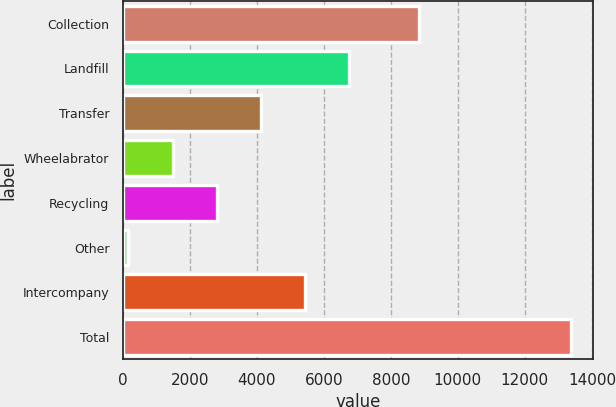<chart> <loc_0><loc_0><loc_500><loc_500><bar_chart><fcel>Collection<fcel>Landfill<fcel>Transfer<fcel>Wheelabrator<fcel>Recycling<fcel>Other<fcel>Intercompany<fcel>Total<nl><fcel>8837<fcel>6766<fcel>4127.2<fcel>1488.4<fcel>2807.8<fcel>169<fcel>5446.6<fcel>13363<nl></chart> 